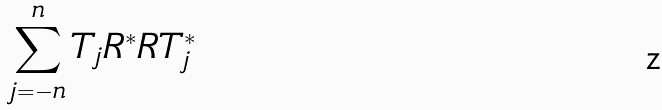<formula> <loc_0><loc_0><loc_500><loc_500>\sum _ { j = - n } ^ { n } T _ { j } R ^ { * } R T _ { j } ^ { * }</formula> 